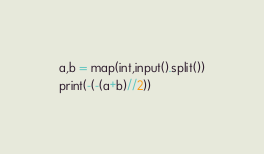<code> <loc_0><loc_0><loc_500><loc_500><_Python_>a,b = map(int,input().split())
print(-(-(a+b)//2))</code> 